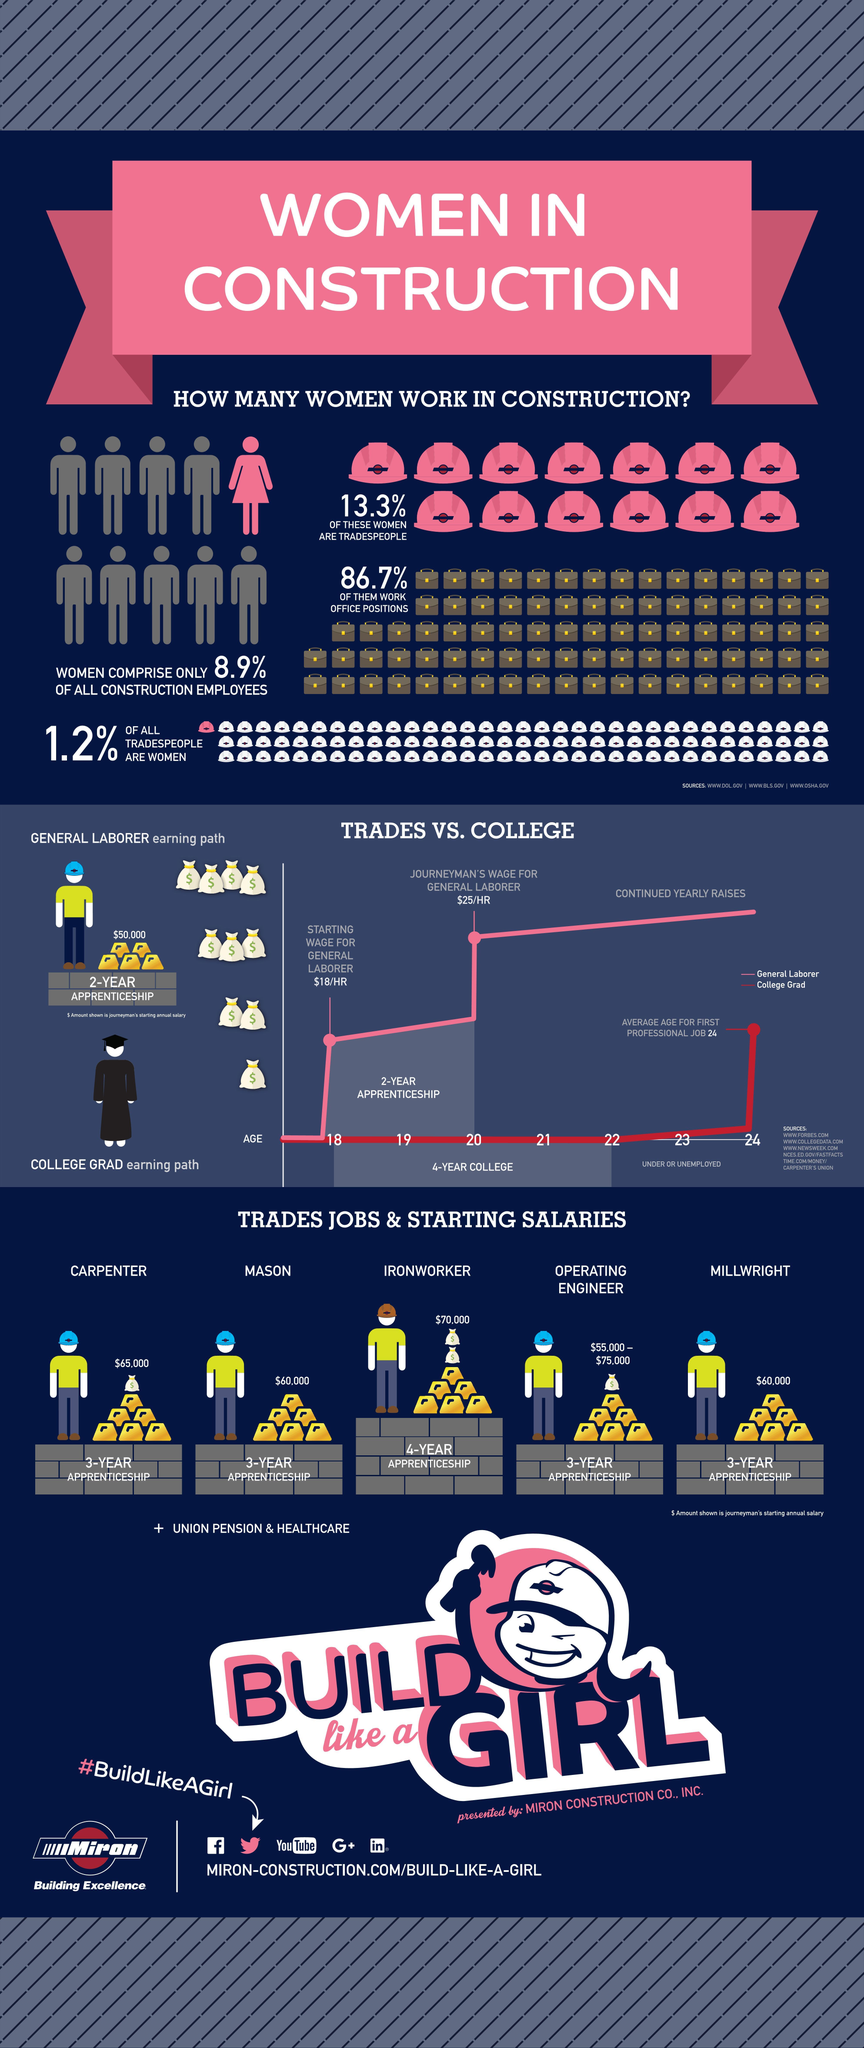What is the starting annual salary of an ironworker?
Answer the question with a short phrase. $70,000 What is the starting annual salary of a mason? $60,000 What percentage of men held office positions in the construction field? 13.3% What is the starting wage for a general labourer? $18/HR 